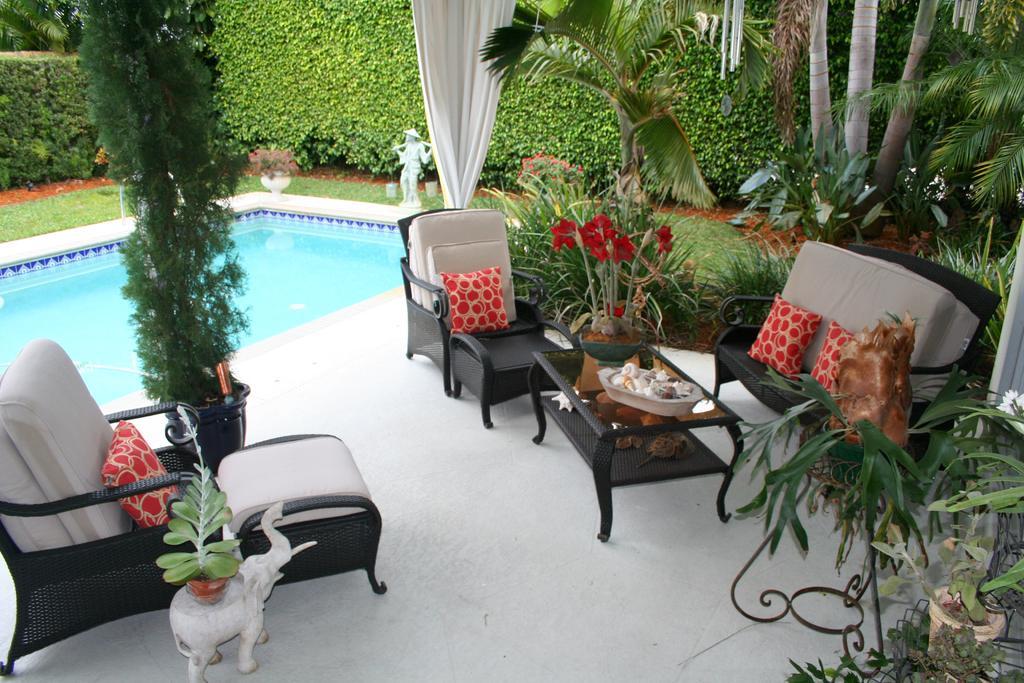Please provide a concise description of this image. In this image there are couches, there is a couch truncated towards the left of the image, there are pillows on the couch, there is a table, there are objects on the table, there are plants truncated towards the right of the image, there are plants truncated towards the top of the image, there are plants truncated towards the left of the image, there is a swimming pool truncated towards the left of the image, there are flower pots, there is the grass, there is a curtain truncated towards the top of the image. 